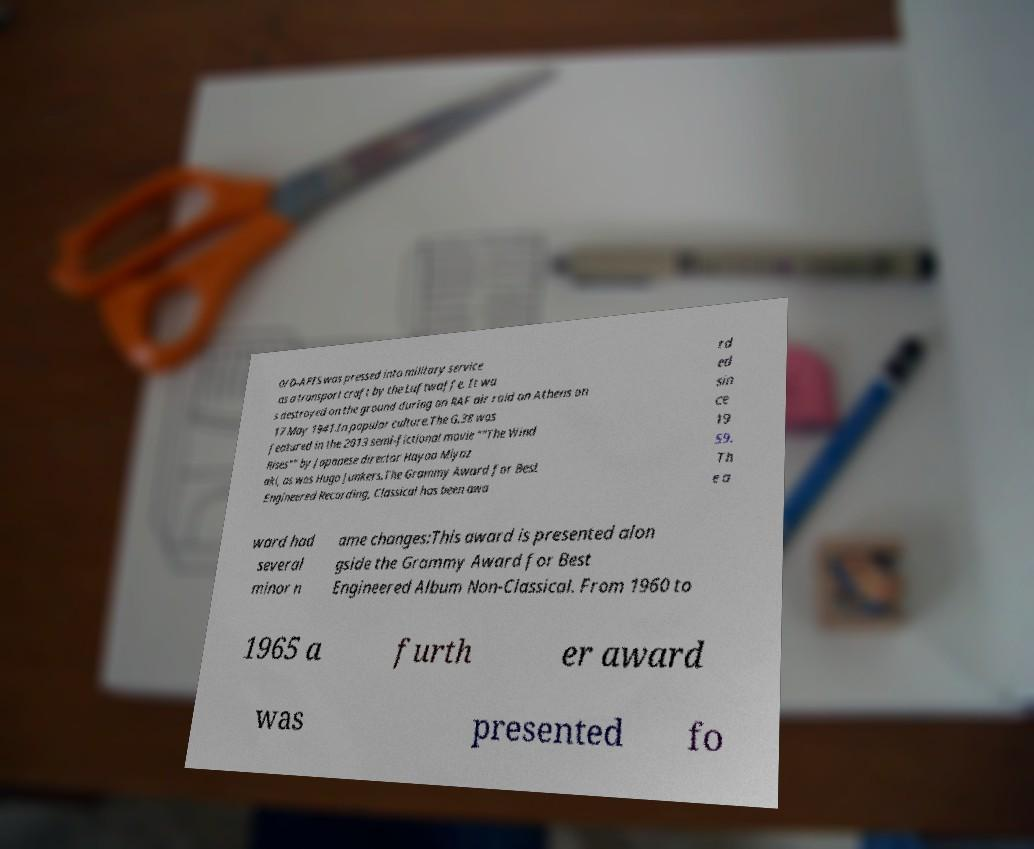Can you read and provide the text displayed in the image?This photo seems to have some interesting text. Can you extract and type it out for me? 0/D-APIS was pressed into military service as a transport craft by the Luftwaffe. It wa s destroyed on the ground during an RAF air raid on Athens on 17 May 1941.In popular culture.The G.38 was featured in the 2013 semi-fictional movie ""The Wind Rises"" by Japanese director Hayao Miyaz aki, as was Hugo Junkers.The Grammy Award for Best Engineered Recording, Classical has been awa rd ed sin ce 19 59. Th e a ward had several minor n ame changes:This award is presented alon gside the Grammy Award for Best Engineered Album Non-Classical. From 1960 to 1965 a furth er award was presented fo 